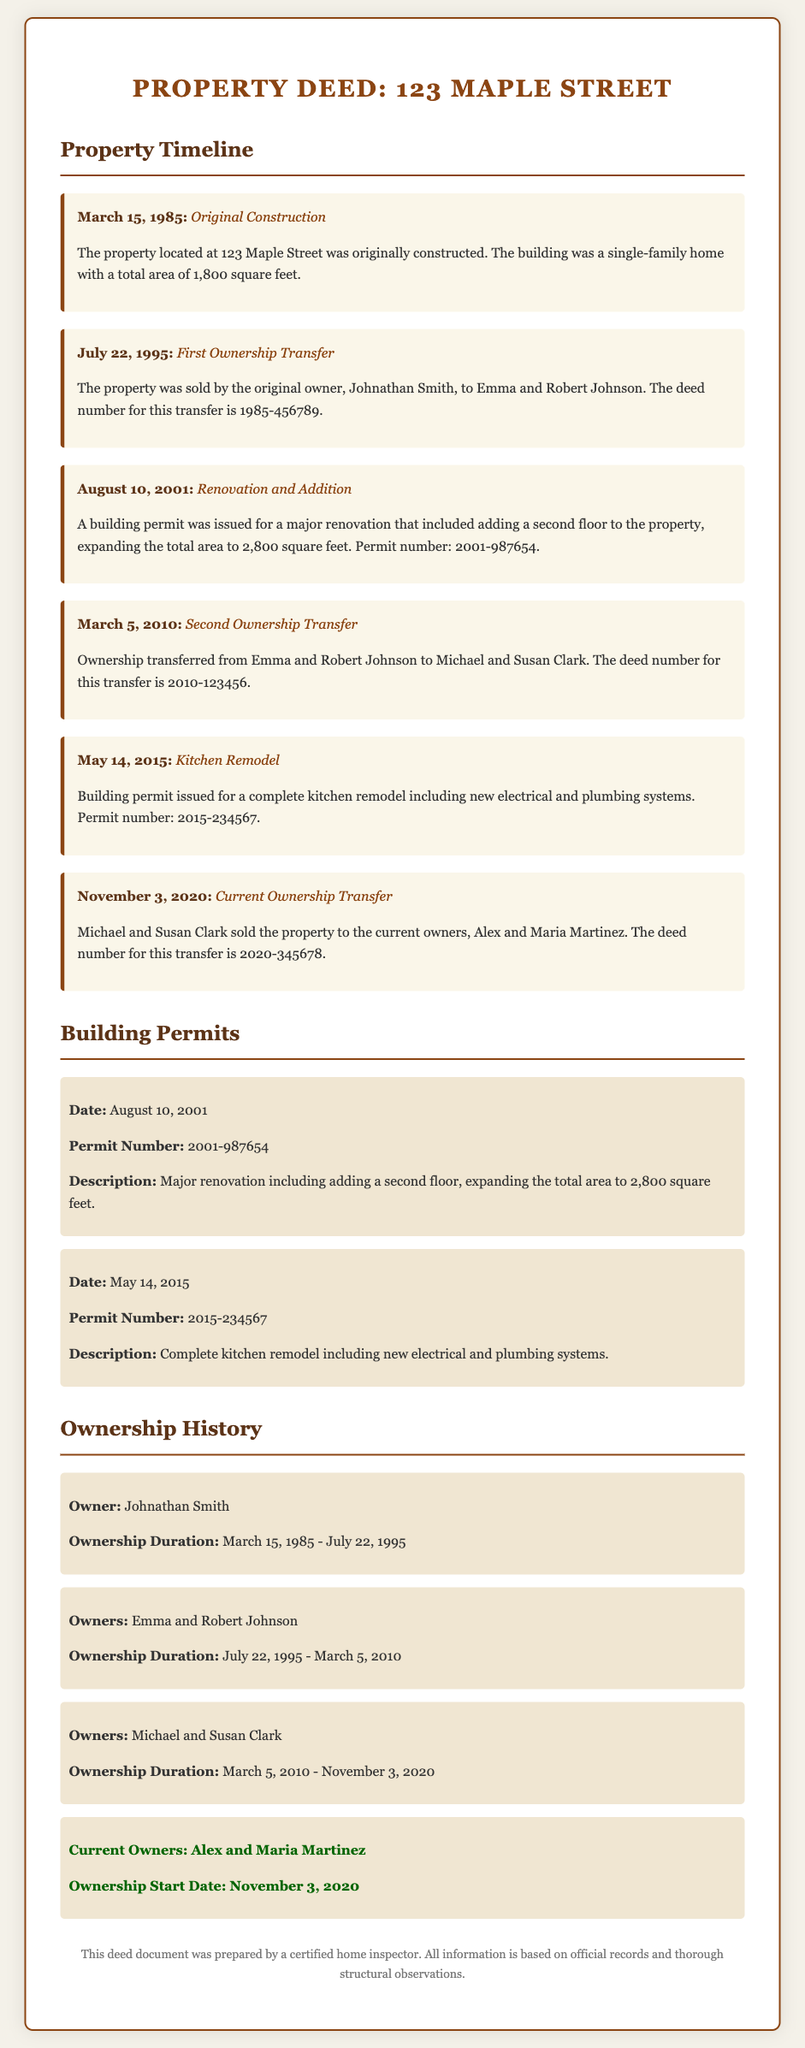What was the original construction date? The original construction date is mentioned in the timeline section of the document.
Answer: March 15, 1985 Who was the first owner of the property? The first owner is listed under the Ownership History section of the document.
Answer: Johnathan Smith What is the total area of the property after renovation? The total area after renovation can be found in the event description of the timeline.
Answer: 2,800 square feet What was the permit number for the kitchen remodel? The permit number for the kitchen remodel is provided in the Building Permits section.
Answer: 2015-234567 How long did Michael and Susan Clark own the property? The ownership duration is given in the Ownership History section.
Answer: March 5, 2010 - November 3, 2020 What type of renovation occurred on August 10, 2001? The type of renovation is described in the timeline event that corresponds to this date.
Answer: Major renovation including adding a second floor Who are the current owners of the property? The current owners are indicated in the Ownership History section and are also highlighted as current owners.
Answer: Alex and Maria Martinez What is the deed number for the first ownership transfer? The deed number for the transfer is stated in the timeline event regarding the first ownership transfer.
Answer: 1985-456789 What was added to the property during the 2001 renovations? The added element is specified in the description of the renovation event in the timeline.
Answer: A second floor 